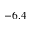Convert formula to latex. <formula><loc_0><loc_0><loc_500><loc_500>- 6 . 4</formula> 